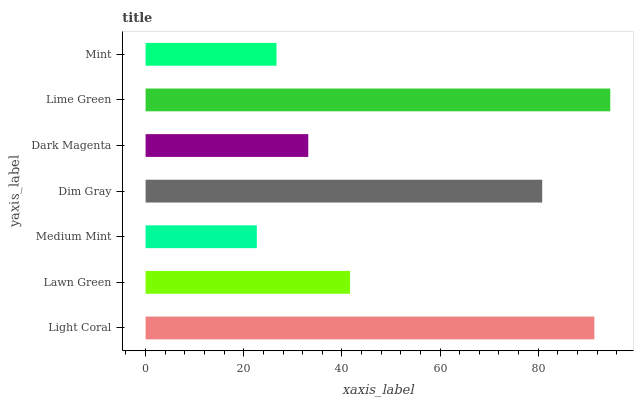Is Medium Mint the minimum?
Answer yes or no. Yes. Is Lime Green the maximum?
Answer yes or no. Yes. Is Lawn Green the minimum?
Answer yes or no. No. Is Lawn Green the maximum?
Answer yes or no. No. Is Light Coral greater than Lawn Green?
Answer yes or no. Yes. Is Lawn Green less than Light Coral?
Answer yes or no. Yes. Is Lawn Green greater than Light Coral?
Answer yes or no. No. Is Light Coral less than Lawn Green?
Answer yes or no. No. Is Lawn Green the high median?
Answer yes or no. Yes. Is Lawn Green the low median?
Answer yes or no. Yes. Is Dark Magenta the high median?
Answer yes or no. No. Is Dark Magenta the low median?
Answer yes or no. No. 